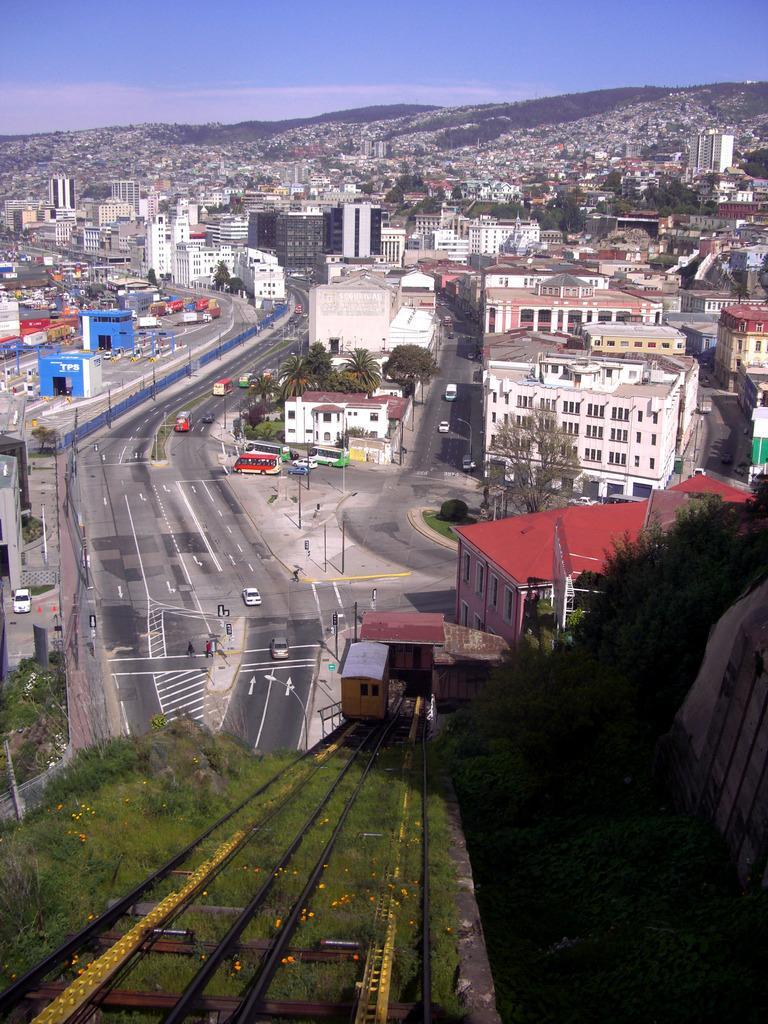Can you describe this image briefly? In this image I see the grass and tracks over here and I see the road on which there are vehicles and I see the trees. In the background I see number of buildings and I see the sky. 